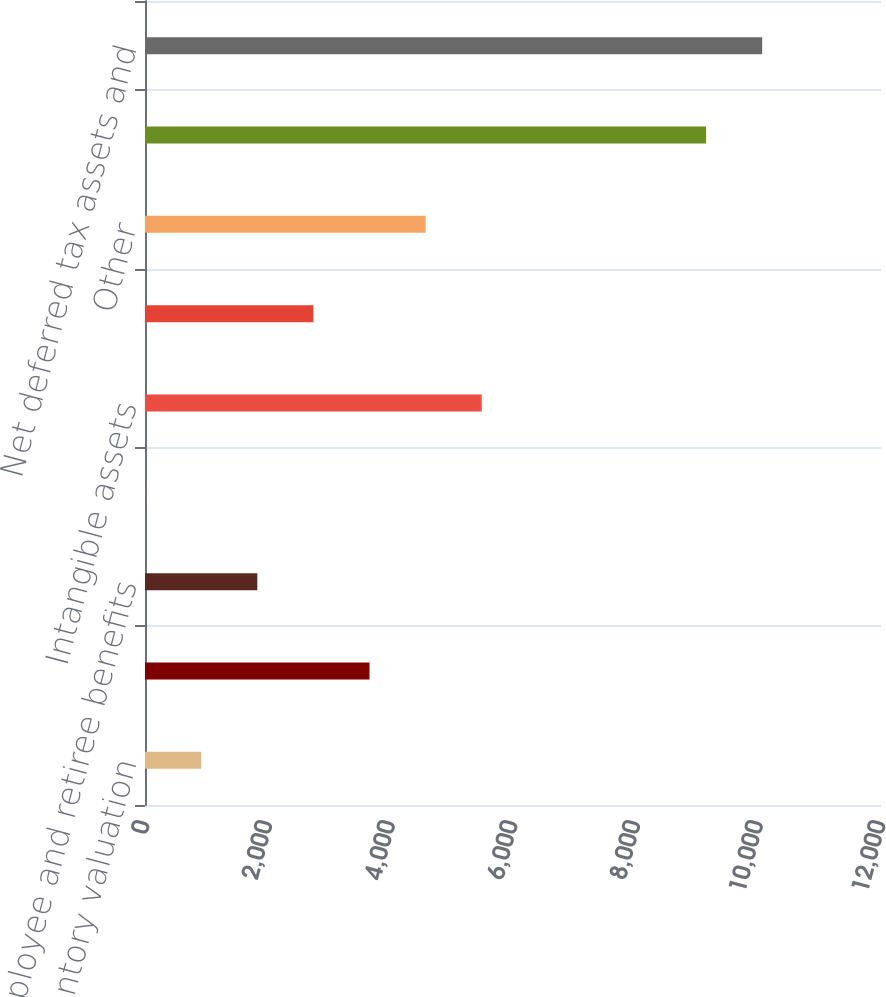<chart> <loc_0><loc_0><loc_500><loc_500><bar_chart><fcel>Inventory valuation<fcel>Fixed assets<fcel>Employee and retiree benefits<fcel>Accounts receivable allowance<fcel>Intangible assets<fcel>Deferred revenue<fcel>Other<fcel>Gross deferred tax assets and<fcel>Net deferred tax assets and<nl><fcel>916.6<fcel>3660.4<fcel>1831.2<fcel>2<fcel>5489.6<fcel>2745.8<fcel>4575<fcel>9148<fcel>10062.6<nl></chart> 